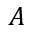<formula> <loc_0><loc_0><loc_500><loc_500>A</formula> 